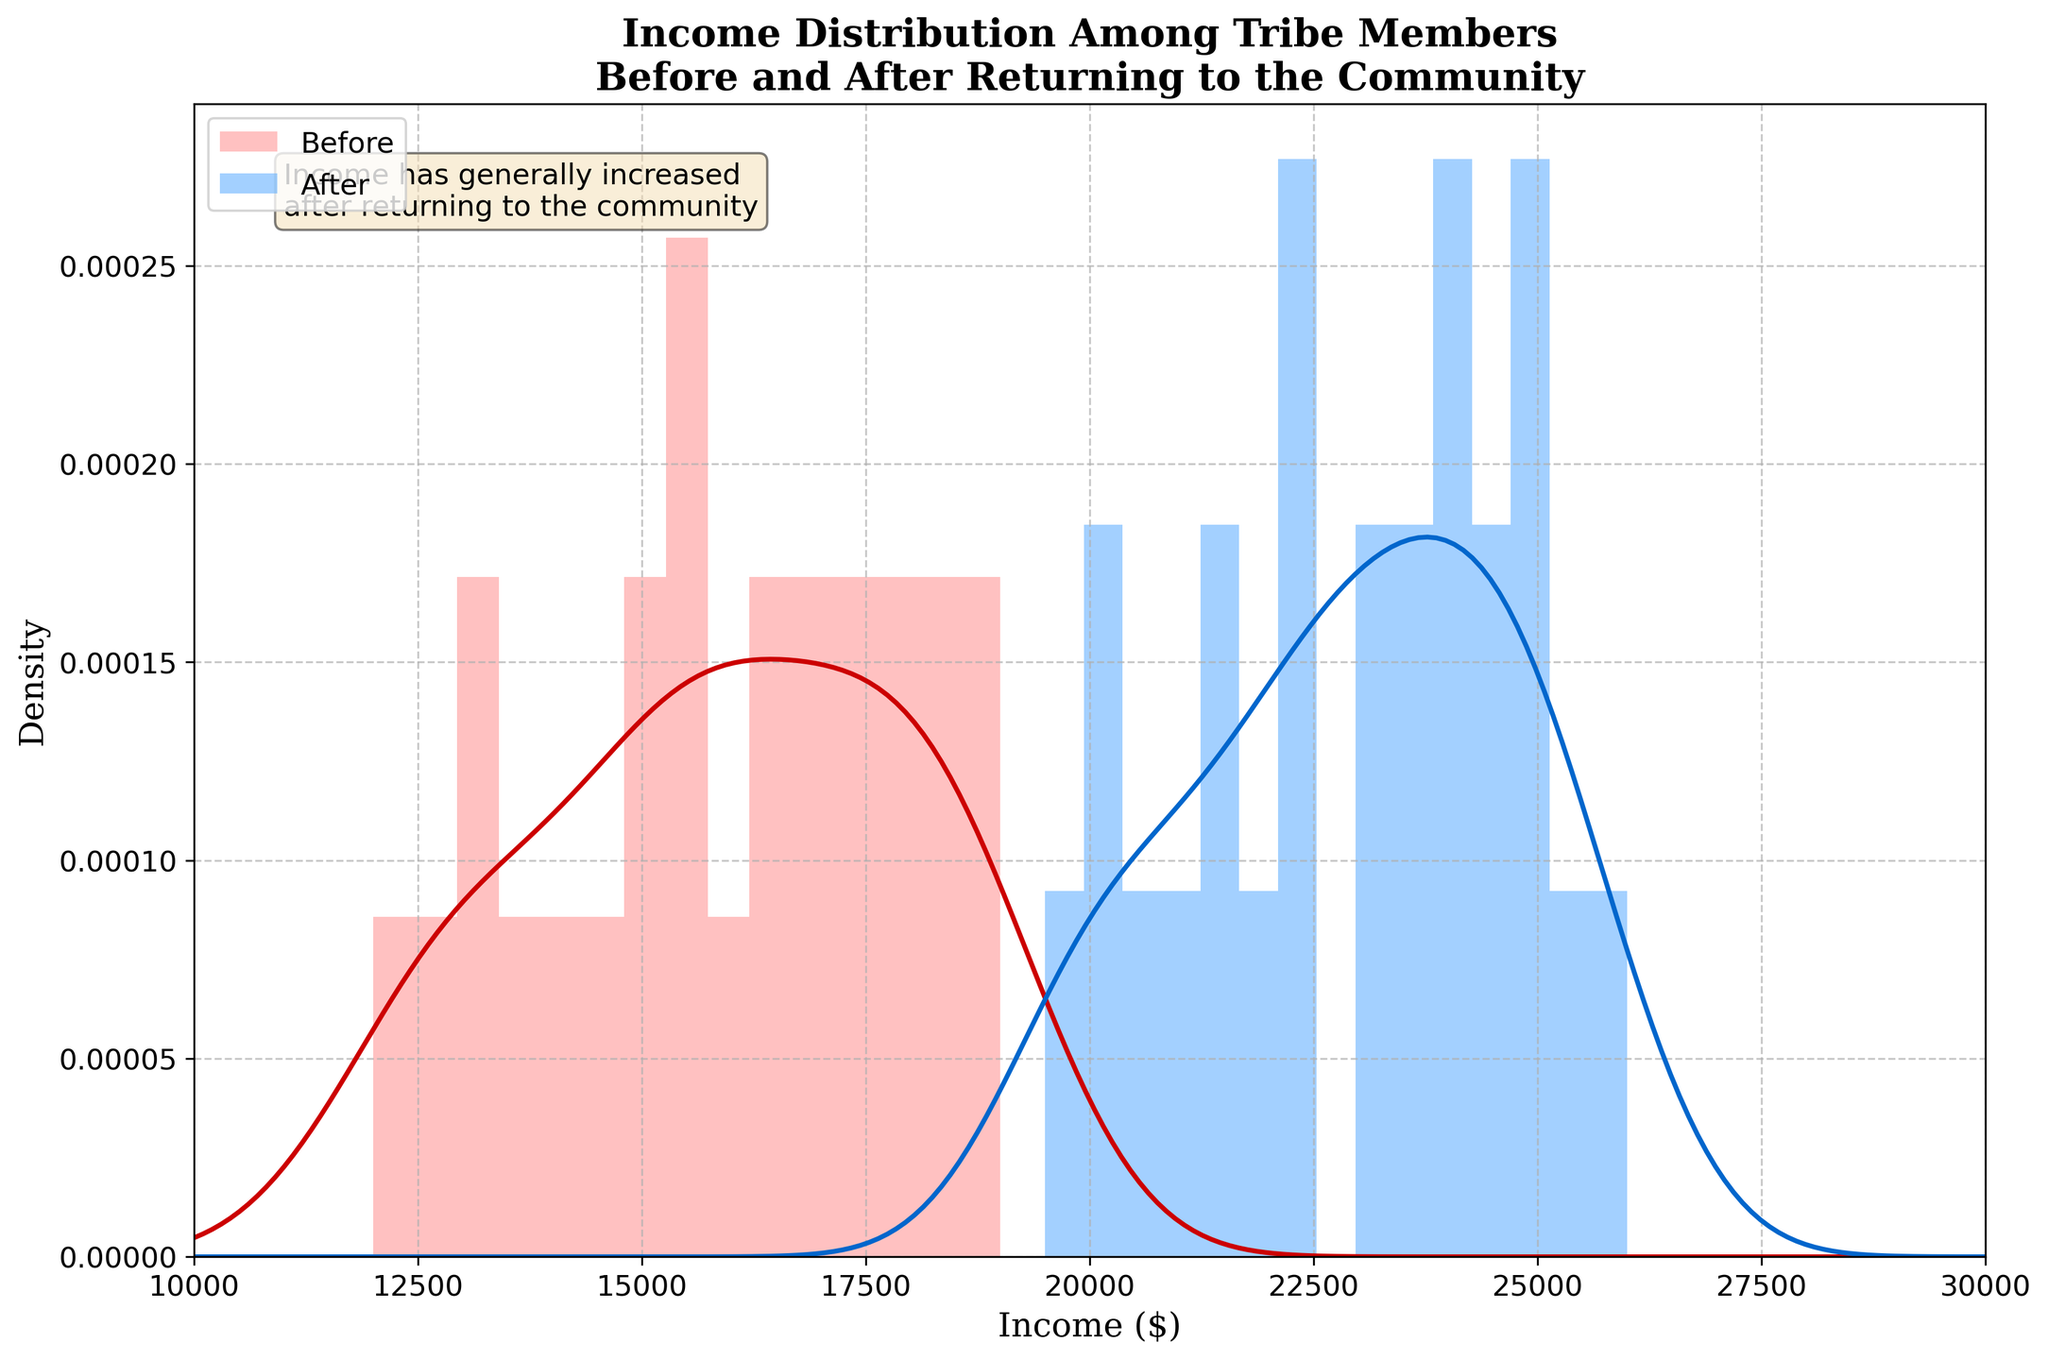What's the title of the figure? The title of the figure is displayed at the top and can be easily read.
Answer: Income Distribution Among Tribe Members Before and After Returning to the Community What do the colors red and blue represent? The color legend shows that red represents income before returning to the community, while blue represents income after returning.
Answer: Red: Before, Blue: After Which period has a higher peak density, before or after returning to the community? By comparing the height of the peaks in the density curves, the blue curve (after returning) has a higher peak density than the red curve (before returning).
Answer: After What's the x-axis range of the plot? The x-axis range is determined by the lowest and highest values on the x-axis.
Answer: 10000 to 30000 Does the text annotation suggest a general trend in income? Yes, the text annotation mentions that income has generally increased after returning to the community.
Answer: Yes What's one specific income value that is present in both the 'Before' and 'After' distributions? By looking at the histogram bars, the income value of 15000 appears in both distributions.
Answer: 15000 Comparing the density curves, which income level shows a significant increase after returning to the community? Observing the blue peak around 23000-26000, these levels show a significant increase compared to their red counterparts.
Answer: 23000-26000 How does the width of income distribution change from 'Before' to 'After'? The width of the 'After' distribution appears more spread out, indicating a wider range of income levels compared to the 'Before' distribution.
Answer: More spread out Is there grid present on the plot? The plot shows light grid lines in the background indicating grid presence.
Answer: Yes Which time period shows a more uniform distribution of income? By comparing the smoothness and spread of both curves, the 'After' distribution is more uniform.
Answer: After 